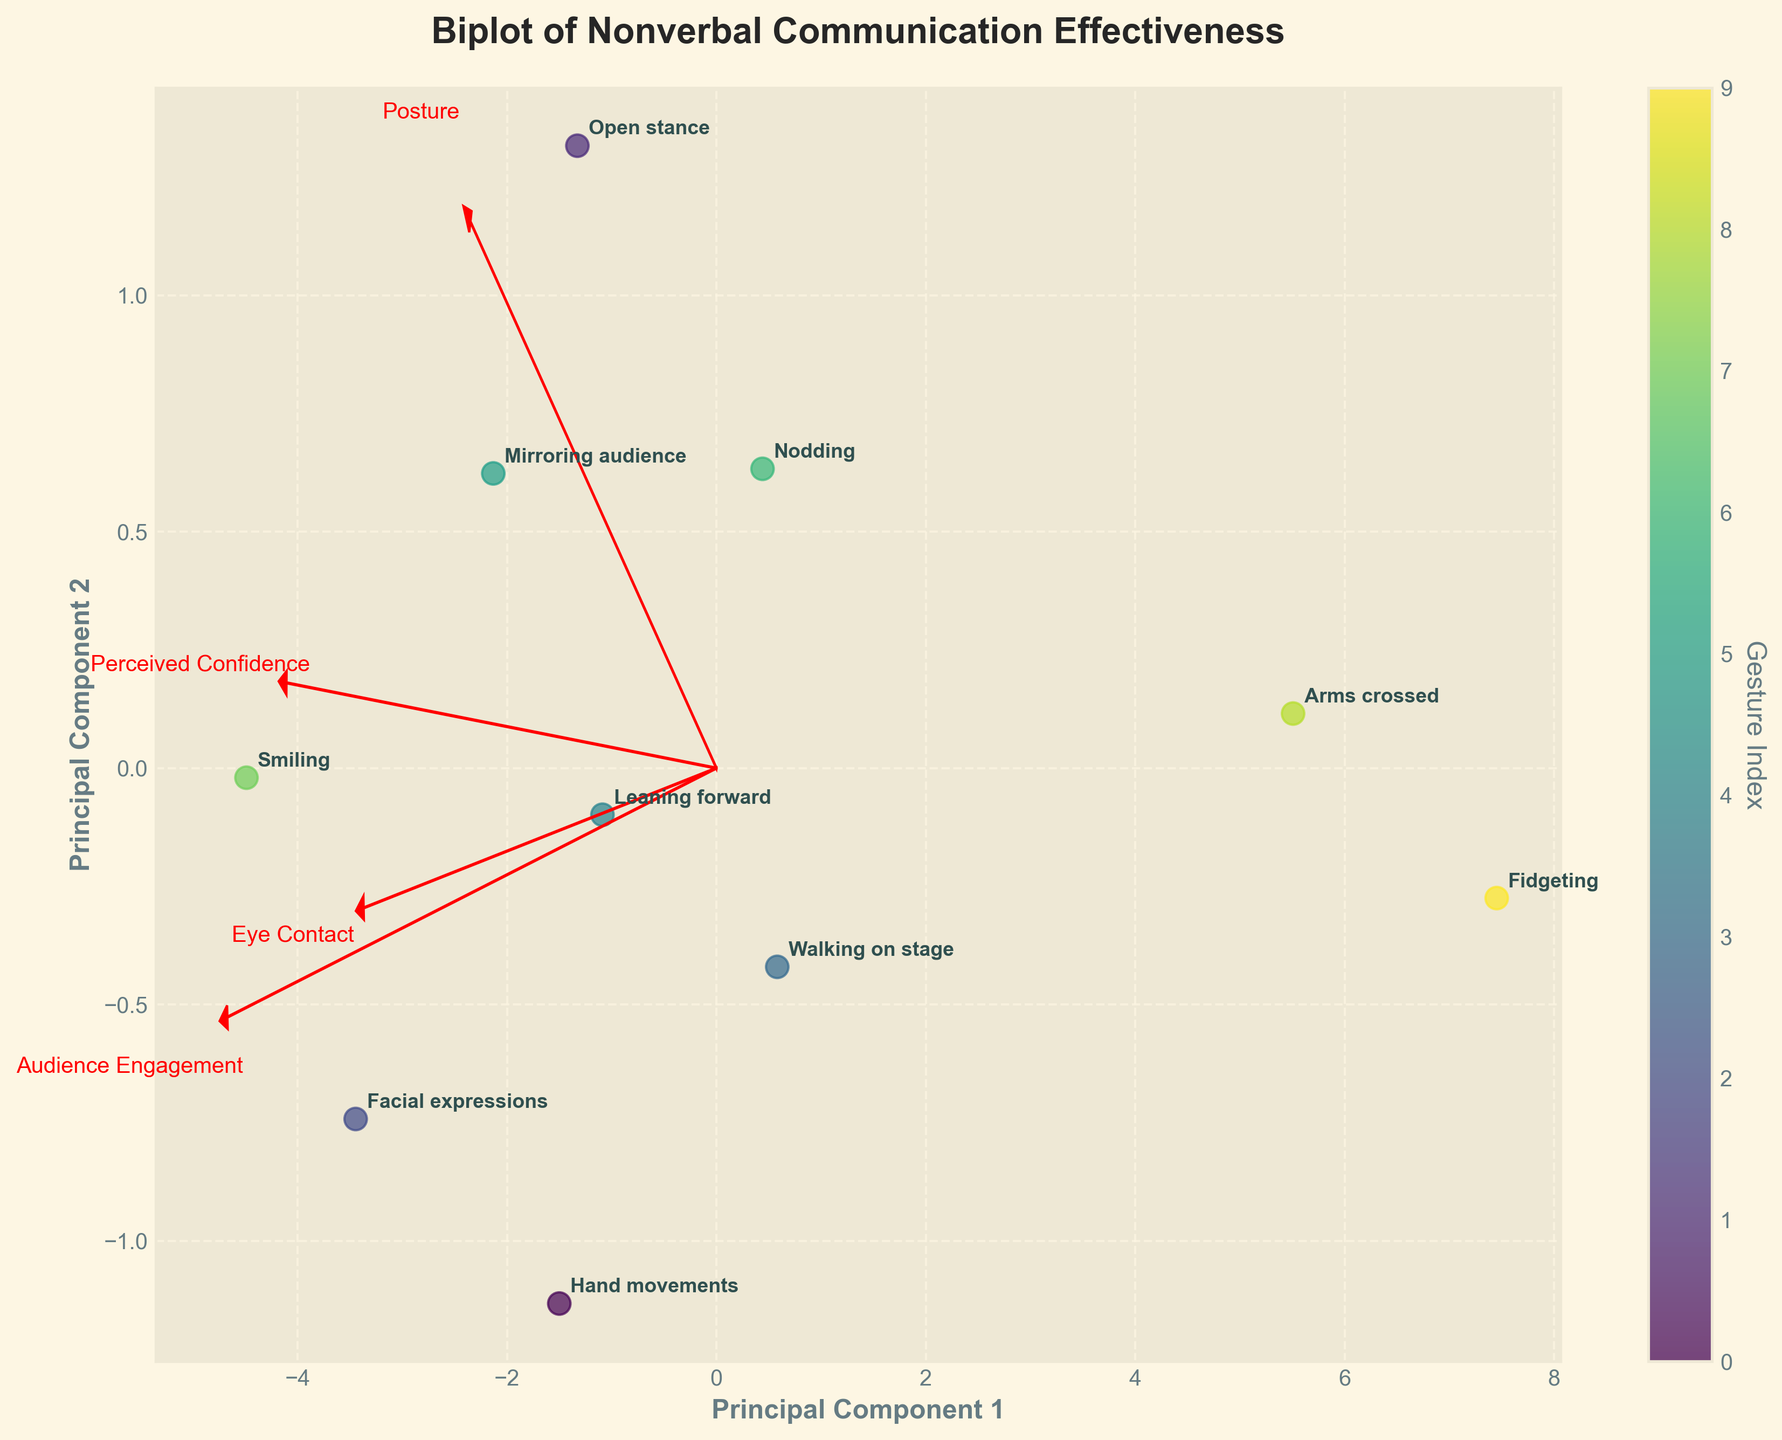What is the title of the biplot? The title is displayed at the top of the plot. It is typically a brief description of what the plot represents.
Answer: Biplot of Nonverbal Communication Effectiveness How many nonverbal communication gestures are represented in the biplot? Each scatter point on the biplot represents a different gesture. By counting the number of scatter points, we can determine the number of gestures. There are 10 scatter points on the plot.
Answer: 10 Which gesture has the highest audience engagement according to the biplot? By looking at the annotations of the points, we can find the one labeled 'Smiling,' which has high principal component scores, indicating a high audience engagement.
Answer: Smiling What features are represented by the red vectors in the biplot? The red vectors correspond to the features labeled in red text at the end of each vector. These labels are located around the plot and point outward from the origin.
Answer: Eye Contact, Posture, Audience Engagement, Perceived Confidence Which gestures are closest to the origin of the biplot? By observing the plot, the gestures that are nearest the intersection of the principal components axes (the origin) are those with smaller principal component scores.
Answer: Walking on stage, Nodding What is the relationship between 'Smiling' and 'Facial expressions' in terms of their position on the biplot? By comparing their positions, 'Smiling' and 'Facial expressions' are both located towards the higher values of the principal components, indicating they are perceived similarly and likely have a high impact on audience engagement and perceived confidence.
Answer: Similar and positive In which direction does the vector representing 'Audience Engagement' point? The direction of the vector can be seen from the red arrow labeled 'Audience Engagement'. It points towards the higher values on the principal component axes.
Answer: Upper right How does 'Fidgeting' compare to 'Hand movements' in terms of audience engagement and perceived confidence? 'Fidgeting' is located towards the lower end of the principal component scores, while 'Hand movements' is more central but still higher by comparison, indicating better audience engagement and perceived confidence.
Answer: 'Hand movements' is higher What do the lengths of the feature vectors represent in the biplot? The lengths of the red vectors represent the importance and contribution of each feature to the principal components. Longer vectors indicate a stronger influence on the principal components.
Answer: Importance and contribution Which two gestures are located furthest apart on the biplot? By observing the spatial distribution of the points, 'Smiling' and 'Fidgeting' are the furthest from each other, indicating a wide difference in audience perception and confidence.
Answer: 'Smiling' and 'Fidgeting' 